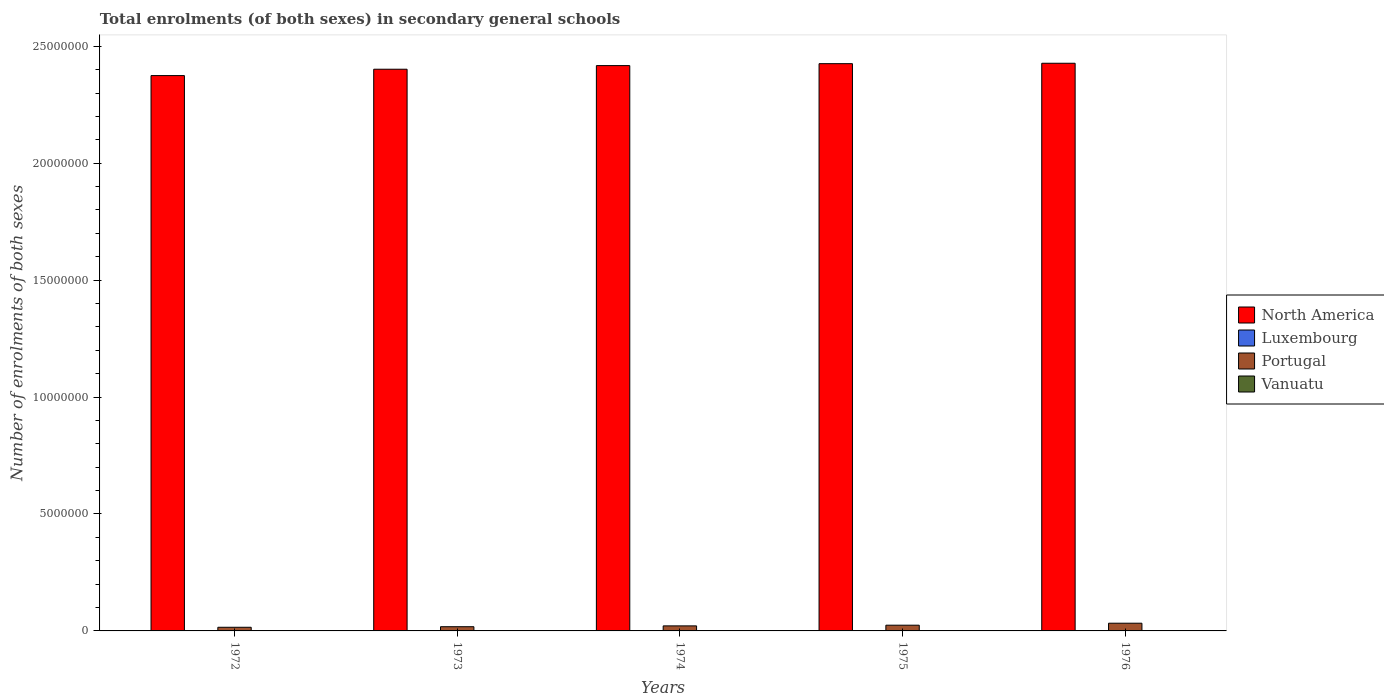How many different coloured bars are there?
Give a very brief answer. 4. Are the number of bars on each tick of the X-axis equal?
Provide a succinct answer. Yes. How many bars are there on the 3rd tick from the left?
Give a very brief answer. 4. How many bars are there on the 2nd tick from the right?
Ensure brevity in your answer.  4. What is the number of enrolments in secondary schools in North America in 1974?
Your response must be concise. 2.42e+07. Across all years, what is the maximum number of enrolments in secondary schools in North America?
Your response must be concise. 2.43e+07. Across all years, what is the minimum number of enrolments in secondary schools in Luxembourg?
Offer a very short reply. 8213. In which year was the number of enrolments in secondary schools in Luxembourg maximum?
Make the answer very short. 1976. In which year was the number of enrolments in secondary schools in Vanuatu minimum?
Make the answer very short. 1972. What is the total number of enrolments in secondary schools in Vanuatu in the graph?
Your answer should be compact. 5290. What is the difference between the number of enrolments in secondary schools in Portugal in 1972 and that in 1973?
Provide a succinct answer. -2.42e+04. What is the difference between the number of enrolments in secondary schools in North America in 1976 and the number of enrolments in secondary schools in Vanuatu in 1972?
Ensure brevity in your answer.  2.43e+07. What is the average number of enrolments in secondary schools in Luxembourg per year?
Keep it short and to the point. 1.11e+04. In the year 1973, what is the difference between the number of enrolments in secondary schools in North America and number of enrolments in secondary schools in Portugal?
Keep it short and to the point. 2.38e+07. In how many years, is the number of enrolments in secondary schools in Vanuatu greater than 23000000?
Offer a terse response. 0. What is the ratio of the number of enrolments in secondary schools in Portugal in 1972 to that in 1973?
Offer a terse response. 0.87. Is the difference between the number of enrolments in secondary schools in North America in 1972 and 1974 greater than the difference between the number of enrolments in secondary schools in Portugal in 1972 and 1974?
Give a very brief answer. No. What is the difference between the highest and the second highest number of enrolments in secondary schools in North America?
Your response must be concise. 1.73e+04. What is the difference between the highest and the lowest number of enrolments in secondary schools in North America?
Offer a terse response. 5.27e+05. In how many years, is the number of enrolments in secondary schools in North America greater than the average number of enrolments in secondary schools in North America taken over all years?
Give a very brief answer. 3. Is the sum of the number of enrolments in secondary schools in Vanuatu in 1973 and 1976 greater than the maximum number of enrolments in secondary schools in North America across all years?
Offer a very short reply. No. What does the 1st bar from the left in 1972 represents?
Your answer should be very brief. North America. Is it the case that in every year, the sum of the number of enrolments in secondary schools in North America and number of enrolments in secondary schools in Vanuatu is greater than the number of enrolments in secondary schools in Luxembourg?
Your response must be concise. Yes. How many bars are there?
Your response must be concise. 20. How many years are there in the graph?
Keep it short and to the point. 5. Are the values on the major ticks of Y-axis written in scientific E-notation?
Make the answer very short. No. Where does the legend appear in the graph?
Your answer should be compact. Center right. How many legend labels are there?
Offer a terse response. 4. How are the legend labels stacked?
Make the answer very short. Vertical. What is the title of the graph?
Give a very brief answer. Total enrolments (of both sexes) in secondary general schools. What is the label or title of the X-axis?
Provide a succinct answer. Years. What is the label or title of the Y-axis?
Provide a short and direct response. Number of enrolments of both sexes. What is the Number of enrolments of both sexes in North America in 1972?
Your answer should be very brief. 2.37e+07. What is the Number of enrolments of both sexes in Luxembourg in 1972?
Offer a very short reply. 8685. What is the Number of enrolments of both sexes in Portugal in 1972?
Make the answer very short. 1.56e+05. What is the Number of enrolments of both sexes of Vanuatu in 1972?
Give a very brief answer. 696. What is the Number of enrolments of both sexes of North America in 1973?
Ensure brevity in your answer.  2.40e+07. What is the Number of enrolments of both sexes of Luxembourg in 1973?
Give a very brief answer. 8425. What is the Number of enrolments of both sexes in Portugal in 1973?
Give a very brief answer. 1.80e+05. What is the Number of enrolments of both sexes of Vanuatu in 1973?
Your answer should be compact. 835. What is the Number of enrolments of both sexes of North America in 1974?
Offer a very short reply. 2.42e+07. What is the Number of enrolments of both sexes in Luxembourg in 1974?
Your answer should be compact. 8213. What is the Number of enrolments of both sexes in Portugal in 1974?
Keep it short and to the point. 2.15e+05. What is the Number of enrolments of both sexes in Vanuatu in 1974?
Offer a terse response. 1016. What is the Number of enrolments of both sexes of North America in 1975?
Give a very brief answer. 2.43e+07. What is the Number of enrolments of both sexes of Luxembourg in 1975?
Keep it short and to the point. 1.50e+04. What is the Number of enrolments of both sexes of Portugal in 1975?
Provide a short and direct response. 2.45e+05. What is the Number of enrolments of both sexes of Vanuatu in 1975?
Offer a very short reply. 1263. What is the Number of enrolments of both sexes of North America in 1976?
Ensure brevity in your answer.  2.43e+07. What is the Number of enrolments of both sexes in Luxembourg in 1976?
Give a very brief answer. 1.52e+04. What is the Number of enrolments of both sexes in Portugal in 1976?
Your answer should be compact. 3.30e+05. What is the Number of enrolments of both sexes of Vanuatu in 1976?
Offer a very short reply. 1480. Across all years, what is the maximum Number of enrolments of both sexes of North America?
Keep it short and to the point. 2.43e+07. Across all years, what is the maximum Number of enrolments of both sexes in Luxembourg?
Your response must be concise. 1.52e+04. Across all years, what is the maximum Number of enrolments of both sexes in Portugal?
Provide a succinct answer. 3.30e+05. Across all years, what is the maximum Number of enrolments of both sexes in Vanuatu?
Make the answer very short. 1480. Across all years, what is the minimum Number of enrolments of both sexes of North America?
Your response must be concise. 2.37e+07. Across all years, what is the minimum Number of enrolments of both sexes in Luxembourg?
Keep it short and to the point. 8213. Across all years, what is the minimum Number of enrolments of both sexes in Portugal?
Offer a terse response. 1.56e+05. Across all years, what is the minimum Number of enrolments of both sexes in Vanuatu?
Ensure brevity in your answer.  696. What is the total Number of enrolments of both sexes in North America in the graph?
Your answer should be compact. 1.20e+08. What is the total Number of enrolments of both sexes of Luxembourg in the graph?
Offer a very short reply. 5.55e+04. What is the total Number of enrolments of both sexes of Portugal in the graph?
Your answer should be very brief. 1.13e+06. What is the total Number of enrolments of both sexes of Vanuatu in the graph?
Your response must be concise. 5290. What is the difference between the Number of enrolments of both sexes of North America in 1972 and that in 1973?
Give a very brief answer. -2.72e+05. What is the difference between the Number of enrolments of both sexes in Luxembourg in 1972 and that in 1973?
Provide a succinct answer. 260. What is the difference between the Number of enrolments of both sexes of Portugal in 1972 and that in 1973?
Provide a short and direct response. -2.42e+04. What is the difference between the Number of enrolments of both sexes of Vanuatu in 1972 and that in 1973?
Your response must be concise. -139. What is the difference between the Number of enrolments of both sexes of North America in 1972 and that in 1974?
Make the answer very short. -4.27e+05. What is the difference between the Number of enrolments of both sexes in Luxembourg in 1972 and that in 1974?
Your response must be concise. 472. What is the difference between the Number of enrolments of both sexes in Portugal in 1972 and that in 1974?
Your response must be concise. -5.97e+04. What is the difference between the Number of enrolments of both sexes in Vanuatu in 1972 and that in 1974?
Ensure brevity in your answer.  -320. What is the difference between the Number of enrolments of both sexes of North America in 1972 and that in 1975?
Make the answer very short. -5.10e+05. What is the difference between the Number of enrolments of both sexes of Luxembourg in 1972 and that in 1975?
Make the answer very short. -6328. What is the difference between the Number of enrolments of both sexes of Portugal in 1972 and that in 1975?
Your answer should be very brief. -8.95e+04. What is the difference between the Number of enrolments of both sexes of Vanuatu in 1972 and that in 1975?
Provide a short and direct response. -567. What is the difference between the Number of enrolments of both sexes in North America in 1972 and that in 1976?
Your response must be concise. -5.27e+05. What is the difference between the Number of enrolments of both sexes of Luxembourg in 1972 and that in 1976?
Your answer should be compact. -6506. What is the difference between the Number of enrolments of both sexes in Portugal in 1972 and that in 1976?
Your answer should be compact. -1.74e+05. What is the difference between the Number of enrolments of both sexes of Vanuatu in 1972 and that in 1976?
Offer a terse response. -784. What is the difference between the Number of enrolments of both sexes of North America in 1973 and that in 1974?
Give a very brief answer. -1.55e+05. What is the difference between the Number of enrolments of both sexes of Luxembourg in 1973 and that in 1974?
Provide a short and direct response. 212. What is the difference between the Number of enrolments of both sexes of Portugal in 1973 and that in 1974?
Your answer should be compact. -3.55e+04. What is the difference between the Number of enrolments of both sexes in Vanuatu in 1973 and that in 1974?
Make the answer very short. -181. What is the difference between the Number of enrolments of both sexes in North America in 1973 and that in 1975?
Keep it short and to the point. -2.38e+05. What is the difference between the Number of enrolments of both sexes in Luxembourg in 1973 and that in 1975?
Offer a terse response. -6588. What is the difference between the Number of enrolments of both sexes in Portugal in 1973 and that in 1975?
Give a very brief answer. -6.53e+04. What is the difference between the Number of enrolments of both sexes in Vanuatu in 1973 and that in 1975?
Make the answer very short. -428. What is the difference between the Number of enrolments of both sexes in North America in 1973 and that in 1976?
Give a very brief answer. -2.55e+05. What is the difference between the Number of enrolments of both sexes of Luxembourg in 1973 and that in 1976?
Provide a succinct answer. -6766. What is the difference between the Number of enrolments of both sexes in Portugal in 1973 and that in 1976?
Ensure brevity in your answer.  -1.50e+05. What is the difference between the Number of enrolments of both sexes in Vanuatu in 1973 and that in 1976?
Give a very brief answer. -645. What is the difference between the Number of enrolments of both sexes of North America in 1974 and that in 1975?
Give a very brief answer. -8.29e+04. What is the difference between the Number of enrolments of both sexes of Luxembourg in 1974 and that in 1975?
Provide a succinct answer. -6800. What is the difference between the Number of enrolments of both sexes of Portugal in 1974 and that in 1975?
Provide a succinct answer. -2.98e+04. What is the difference between the Number of enrolments of both sexes of Vanuatu in 1974 and that in 1975?
Your response must be concise. -247. What is the difference between the Number of enrolments of both sexes of North America in 1974 and that in 1976?
Make the answer very short. -1.00e+05. What is the difference between the Number of enrolments of both sexes in Luxembourg in 1974 and that in 1976?
Provide a short and direct response. -6978. What is the difference between the Number of enrolments of both sexes in Portugal in 1974 and that in 1976?
Ensure brevity in your answer.  -1.15e+05. What is the difference between the Number of enrolments of both sexes of Vanuatu in 1974 and that in 1976?
Give a very brief answer. -464. What is the difference between the Number of enrolments of both sexes in North America in 1975 and that in 1976?
Offer a terse response. -1.73e+04. What is the difference between the Number of enrolments of both sexes in Luxembourg in 1975 and that in 1976?
Offer a very short reply. -178. What is the difference between the Number of enrolments of both sexes in Portugal in 1975 and that in 1976?
Your response must be concise. -8.48e+04. What is the difference between the Number of enrolments of both sexes of Vanuatu in 1975 and that in 1976?
Offer a terse response. -217. What is the difference between the Number of enrolments of both sexes of North America in 1972 and the Number of enrolments of both sexes of Luxembourg in 1973?
Ensure brevity in your answer.  2.37e+07. What is the difference between the Number of enrolments of both sexes in North America in 1972 and the Number of enrolments of both sexes in Portugal in 1973?
Give a very brief answer. 2.36e+07. What is the difference between the Number of enrolments of both sexes in North America in 1972 and the Number of enrolments of both sexes in Vanuatu in 1973?
Offer a very short reply. 2.37e+07. What is the difference between the Number of enrolments of both sexes in Luxembourg in 1972 and the Number of enrolments of both sexes in Portugal in 1973?
Give a very brief answer. -1.71e+05. What is the difference between the Number of enrolments of both sexes of Luxembourg in 1972 and the Number of enrolments of both sexes of Vanuatu in 1973?
Give a very brief answer. 7850. What is the difference between the Number of enrolments of both sexes in Portugal in 1972 and the Number of enrolments of both sexes in Vanuatu in 1973?
Your response must be concise. 1.55e+05. What is the difference between the Number of enrolments of both sexes in North America in 1972 and the Number of enrolments of both sexes in Luxembourg in 1974?
Your answer should be compact. 2.37e+07. What is the difference between the Number of enrolments of both sexes of North America in 1972 and the Number of enrolments of both sexes of Portugal in 1974?
Ensure brevity in your answer.  2.35e+07. What is the difference between the Number of enrolments of both sexes of North America in 1972 and the Number of enrolments of both sexes of Vanuatu in 1974?
Provide a short and direct response. 2.37e+07. What is the difference between the Number of enrolments of both sexes of Luxembourg in 1972 and the Number of enrolments of both sexes of Portugal in 1974?
Provide a short and direct response. -2.07e+05. What is the difference between the Number of enrolments of both sexes in Luxembourg in 1972 and the Number of enrolments of both sexes in Vanuatu in 1974?
Your answer should be very brief. 7669. What is the difference between the Number of enrolments of both sexes in Portugal in 1972 and the Number of enrolments of both sexes in Vanuatu in 1974?
Your answer should be compact. 1.55e+05. What is the difference between the Number of enrolments of both sexes of North America in 1972 and the Number of enrolments of both sexes of Luxembourg in 1975?
Keep it short and to the point. 2.37e+07. What is the difference between the Number of enrolments of both sexes of North America in 1972 and the Number of enrolments of both sexes of Portugal in 1975?
Your answer should be very brief. 2.35e+07. What is the difference between the Number of enrolments of both sexes of North America in 1972 and the Number of enrolments of both sexes of Vanuatu in 1975?
Make the answer very short. 2.37e+07. What is the difference between the Number of enrolments of both sexes of Luxembourg in 1972 and the Number of enrolments of both sexes of Portugal in 1975?
Your response must be concise. -2.36e+05. What is the difference between the Number of enrolments of both sexes in Luxembourg in 1972 and the Number of enrolments of both sexes in Vanuatu in 1975?
Your response must be concise. 7422. What is the difference between the Number of enrolments of both sexes in Portugal in 1972 and the Number of enrolments of both sexes in Vanuatu in 1975?
Give a very brief answer. 1.54e+05. What is the difference between the Number of enrolments of both sexes of North America in 1972 and the Number of enrolments of both sexes of Luxembourg in 1976?
Offer a terse response. 2.37e+07. What is the difference between the Number of enrolments of both sexes of North America in 1972 and the Number of enrolments of both sexes of Portugal in 1976?
Give a very brief answer. 2.34e+07. What is the difference between the Number of enrolments of both sexes of North America in 1972 and the Number of enrolments of both sexes of Vanuatu in 1976?
Your response must be concise. 2.37e+07. What is the difference between the Number of enrolments of both sexes of Luxembourg in 1972 and the Number of enrolments of both sexes of Portugal in 1976?
Provide a succinct answer. -3.21e+05. What is the difference between the Number of enrolments of both sexes of Luxembourg in 1972 and the Number of enrolments of both sexes of Vanuatu in 1976?
Make the answer very short. 7205. What is the difference between the Number of enrolments of both sexes of Portugal in 1972 and the Number of enrolments of both sexes of Vanuatu in 1976?
Your response must be concise. 1.54e+05. What is the difference between the Number of enrolments of both sexes of North America in 1973 and the Number of enrolments of both sexes of Luxembourg in 1974?
Your answer should be very brief. 2.40e+07. What is the difference between the Number of enrolments of both sexes of North America in 1973 and the Number of enrolments of both sexes of Portugal in 1974?
Ensure brevity in your answer.  2.38e+07. What is the difference between the Number of enrolments of both sexes of North America in 1973 and the Number of enrolments of both sexes of Vanuatu in 1974?
Offer a terse response. 2.40e+07. What is the difference between the Number of enrolments of both sexes of Luxembourg in 1973 and the Number of enrolments of both sexes of Portugal in 1974?
Provide a short and direct response. -2.07e+05. What is the difference between the Number of enrolments of both sexes of Luxembourg in 1973 and the Number of enrolments of both sexes of Vanuatu in 1974?
Make the answer very short. 7409. What is the difference between the Number of enrolments of both sexes in Portugal in 1973 and the Number of enrolments of both sexes in Vanuatu in 1974?
Provide a short and direct response. 1.79e+05. What is the difference between the Number of enrolments of both sexes of North America in 1973 and the Number of enrolments of both sexes of Luxembourg in 1975?
Offer a very short reply. 2.40e+07. What is the difference between the Number of enrolments of both sexes in North America in 1973 and the Number of enrolments of both sexes in Portugal in 1975?
Your answer should be very brief. 2.38e+07. What is the difference between the Number of enrolments of both sexes in North America in 1973 and the Number of enrolments of both sexes in Vanuatu in 1975?
Your answer should be compact. 2.40e+07. What is the difference between the Number of enrolments of both sexes of Luxembourg in 1973 and the Number of enrolments of both sexes of Portugal in 1975?
Give a very brief answer. -2.37e+05. What is the difference between the Number of enrolments of both sexes of Luxembourg in 1973 and the Number of enrolments of both sexes of Vanuatu in 1975?
Provide a succinct answer. 7162. What is the difference between the Number of enrolments of both sexes in Portugal in 1973 and the Number of enrolments of both sexes in Vanuatu in 1975?
Provide a short and direct response. 1.79e+05. What is the difference between the Number of enrolments of both sexes in North America in 1973 and the Number of enrolments of both sexes in Luxembourg in 1976?
Ensure brevity in your answer.  2.40e+07. What is the difference between the Number of enrolments of both sexes of North America in 1973 and the Number of enrolments of both sexes of Portugal in 1976?
Offer a very short reply. 2.37e+07. What is the difference between the Number of enrolments of both sexes in North America in 1973 and the Number of enrolments of both sexes in Vanuatu in 1976?
Offer a terse response. 2.40e+07. What is the difference between the Number of enrolments of both sexes of Luxembourg in 1973 and the Number of enrolments of both sexes of Portugal in 1976?
Give a very brief answer. -3.22e+05. What is the difference between the Number of enrolments of both sexes of Luxembourg in 1973 and the Number of enrolments of both sexes of Vanuatu in 1976?
Provide a succinct answer. 6945. What is the difference between the Number of enrolments of both sexes in Portugal in 1973 and the Number of enrolments of both sexes in Vanuatu in 1976?
Make the answer very short. 1.78e+05. What is the difference between the Number of enrolments of both sexes in North America in 1974 and the Number of enrolments of both sexes in Luxembourg in 1975?
Your answer should be very brief. 2.42e+07. What is the difference between the Number of enrolments of both sexes of North America in 1974 and the Number of enrolments of both sexes of Portugal in 1975?
Your answer should be compact. 2.39e+07. What is the difference between the Number of enrolments of both sexes of North America in 1974 and the Number of enrolments of both sexes of Vanuatu in 1975?
Provide a short and direct response. 2.42e+07. What is the difference between the Number of enrolments of both sexes of Luxembourg in 1974 and the Number of enrolments of both sexes of Portugal in 1975?
Make the answer very short. -2.37e+05. What is the difference between the Number of enrolments of both sexes in Luxembourg in 1974 and the Number of enrolments of both sexes in Vanuatu in 1975?
Offer a terse response. 6950. What is the difference between the Number of enrolments of both sexes of Portugal in 1974 and the Number of enrolments of both sexes of Vanuatu in 1975?
Make the answer very short. 2.14e+05. What is the difference between the Number of enrolments of both sexes of North America in 1974 and the Number of enrolments of both sexes of Luxembourg in 1976?
Offer a very short reply. 2.42e+07. What is the difference between the Number of enrolments of both sexes in North America in 1974 and the Number of enrolments of both sexes in Portugal in 1976?
Offer a very short reply. 2.38e+07. What is the difference between the Number of enrolments of both sexes in North America in 1974 and the Number of enrolments of both sexes in Vanuatu in 1976?
Your response must be concise. 2.42e+07. What is the difference between the Number of enrolments of both sexes in Luxembourg in 1974 and the Number of enrolments of both sexes in Portugal in 1976?
Provide a short and direct response. -3.22e+05. What is the difference between the Number of enrolments of both sexes in Luxembourg in 1974 and the Number of enrolments of both sexes in Vanuatu in 1976?
Your answer should be very brief. 6733. What is the difference between the Number of enrolments of both sexes in Portugal in 1974 and the Number of enrolments of both sexes in Vanuatu in 1976?
Your answer should be compact. 2.14e+05. What is the difference between the Number of enrolments of both sexes of North America in 1975 and the Number of enrolments of both sexes of Luxembourg in 1976?
Provide a short and direct response. 2.42e+07. What is the difference between the Number of enrolments of both sexes of North America in 1975 and the Number of enrolments of both sexes of Portugal in 1976?
Provide a succinct answer. 2.39e+07. What is the difference between the Number of enrolments of both sexes in North America in 1975 and the Number of enrolments of both sexes in Vanuatu in 1976?
Offer a terse response. 2.43e+07. What is the difference between the Number of enrolments of both sexes of Luxembourg in 1975 and the Number of enrolments of both sexes of Portugal in 1976?
Offer a very short reply. -3.15e+05. What is the difference between the Number of enrolments of both sexes of Luxembourg in 1975 and the Number of enrolments of both sexes of Vanuatu in 1976?
Offer a terse response. 1.35e+04. What is the difference between the Number of enrolments of both sexes of Portugal in 1975 and the Number of enrolments of both sexes of Vanuatu in 1976?
Offer a terse response. 2.44e+05. What is the average Number of enrolments of both sexes in North America per year?
Your response must be concise. 2.41e+07. What is the average Number of enrolments of both sexes of Luxembourg per year?
Ensure brevity in your answer.  1.11e+04. What is the average Number of enrolments of both sexes of Portugal per year?
Make the answer very short. 2.25e+05. What is the average Number of enrolments of both sexes of Vanuatu per year?
Your response must be concise. 1058. In the year 1972, what is the difference between the Number of enrolments of both sexes of North America and Number of enrolments of both sexes of Luxembourg?
Give a very brief answer. 2.37e+07. In the year 1972, what is the difference between the Number of enrolments of both sexes of North America and Number of enrolments of both sexes of Portugal?
Offer a terse response. 2.36e+07. In the year 1972, what is the difference between the Number of enrolments of both sexes of North America and Number of enrolments of both sexes of Vanuatu?
Give a very brief answer. 2.37e+07. In the year 1972, what is the difference between the Number of enrolments of both sexes of Luxembourg and Number of enrolments of both sexes of Portugal?
Offer a very short reply. -1.47e+05. In the year 1972, what is the difference between the Number of enrolments of both sexes in Luxembourg and Number of enrolments of both sexes in Vanuatu?
Keep it short and to the point. 7989. In the year 1972, what is the difference between the Number of enrolments of both sexes in Portugal and Number of enrolments of both sexes in Vanuatu?
Ensure brevity in your answer.  1.55e+05. In the year 1973, what is the difference between the Number of enrolments of both sexes of North America and Number of enrolments of both sexes of Luxembourg?
Provide a short and direct response. 2.40e+07. In the year 1973, what is the difference between the Number of enrolments of both sexes of North America and Number of enrolments of both sexes of Portugal?
Offer a terse response. 2.38e+07. In the year 1973, what is the difference between the Number of enrolments of both sexes of North America and Number of enrolments of both sexes of Vanuatu?
Ensure brevity in your answer.  2.40e+07. In the year 1973, what is the difference between the Number of enrolments of both sexes in Luxembourg and Number of enrolments of both sexes in Portugal?
Offer a terse response. -1.71e+05. In the year 1973, what is the difference between the Number of enrolments of both sexes in Luxembourg and Number of enrolments of both sexes in Vanuatu?
Provide a succinct answer. 7590. In the year 1973, what is the difference between the Number of enrolments of both sexes in Portugal and Number of enrolments of both sexes in Vanuatu?
Offer a very short reply. 1.79e+05. In the year 1974, what is the difference between the Number of enrolments of both sexes of North America and Number of enrolments of both sexes of Luxembourg?
Provide a short and direct response. 2.42e+07. In the year 1974, what is the difference between the Number of enrolments of both sexes of North America and Number of enrolments of both sexes of Portugal?
Offer a very short reply. 2.40e+07. In the year 1974, what is the difference between the Number of enrolments of both sexes in North America and Number of enrolments of both sexes in Vanuatu?
Make the answer very short. 2.42e+07. In the year 1974, what is the difference between the Number of enrolments of both sexes in Luxembourg and Number of enrolments of both sexes in Portugal?
Give a very brief answer. -2.07e+05. In the year 1974, what is the difference between the Number of enrolments of both sexes in Luxembourg and Number of enrolments of both sexes in Vanuatu?
Your answer should be very brief. 7197. In the year 1974, what is the difference between the Number of enrolments of both sexes in Portugal and Number of enrolments of both sexes in Vanuatu?
Give a very brief answer. 2.14e+05. In the year 1975, what is the difference between the Number of enrolments of both sexes of North America and Number of enrolments of both sexes of Luxembourg?
Offer a very short reply. 2.42e+07. In the year 1975, what is the difference between the Number of enrolments of both sexes in North America and Number of enrolments of both sexes in Portugal?
Offer a terse response. 2.40e+07. In the year 1975, what is the difference between the Number of enrolments of both sexes in North America and Number of enrolments of both sexes in Vanuatu?
Offer a very short reply. 2.43e+07. In the year 1975, what is the difference between the Number of enrolments of both sexes in Luxembourg and Number of enrolments of both sexes in Portugal?
Your response must be concise. -2.30e+05. In the year 1975, what is the difference between the Number of enrolments of both sexes of Luxembourg and Number of enrolments of both sexes of Vanuatu?
Offer a terse response. 1.38e+04. In the year 1975, what is the difference between the Number of enrolments of both sexes in Portugal and Number of enrolments of both sexes in Vanuatu?
Provide a short and direct response. 2.44e+05. In the year 1976, what is the difference between the Number of enrolments of both sexes in North America and Number of enrolments of both sexes in Luxembourg?
Offer a very short reply. 2.43e+07. In the year 1976, what is the difference between the Number of enrolments of both sexes in North America and Number of enrolments of both sexes in Portugal?
Offer a very short reply. 2.39e+07. In the year 1976, what is the difference between the Number of enrolments of both sexes of North America and Number of enrolments of both sexes of Vanuatu?
Make the answer very short. 2.43e+07. In the year 1976, what is the difference between the Number of enrolments of both sexes in Luxembourg and Number of enrolments of both sexes in Portugal?
Provide a succinct answer. -3.15e+05. In the year 1976, what is the difference between the Number of enrolments of both sexes of Luxembourg and Number of enrolments of both sexes of Vanuatu?
Make the answer very short. 1.37e+04. In the year 1976, what is the difference between the Number of enrolments of both sexes of Portugal and Number of enrolments of both sexes of Vanuatu?
Give a very brief answer. 3.29e+05. What is the ratio of the Number of enrolments of both sexes of North America in 1972 to that in 1973?
Ensure brevity in your answer.  0.99. What is the ratio of the Number of enrolments of both sexes in Luxembourg in 1972 to that in 1973?
Give a very brief answer. 1.03. What is the ratio of the Number of enrolments of both sexes of Portugal in 1972 to that in 1973?
Provide a short and direct response. 0.87. What is the ratio of the Number of enrolments of both sexes of Vanuatu in 1972 to that in 1973?
Keep it short and to the point. 0.83. What is the ratio of the Number of enrolments of both sexes in North America in 1972 to that in 1974?
Your answer should be very brief. 0.98. What is the ratio of the Number of enrolments of both sexes of Luxembourg in 1972 to that in 1974?
Keep it short and to the point. 1.06. What is the ratio of the Number of enrolments of both sexes in Portugal in 1972 to that in 1974?
Your answer should be compact. 0.72. What is the ratio of the Number of enrolments of both sexes in Vanuatu in 1972 to that in 1974?
Give a very brief answer. 0.69. What is the ratio of the Number of enrolments of both sexes in Luxembourg in 1972 to that in 1975?
Your answer should be very brief. 0.58. What is the ratio of the Number of enrolments of both sexes of Portugal in 1972 to that in 1975?
Ensure brevity in your answer.  0.64. What is the ratio of the Number of enrolments of both sexes of Vanuatu in 1972 to that in 1975?
Provide a short and direct response. 0.55. What is the ratio of the Number of enrolments of both sexes of North America in 1972 to that in 1976?
Offer a very short reply. 0.98. What is the ratio of the Number of enrolments of both sexes of Luxembourg in 1972 to that in 1976?
Give a very brief answer. 0.57. What is the ratio of the Number of enrolments of both sexes of Portugal in 1972 to that in 1976?
Your answer should be compact. 0.47. What is the ratio of the Number of enrolments of both sexes in Vanuatu in 1972 to that in 1976?
Offer a very short reply. 0.47. What is the ratio of the Number of enrolments of both sexes in North America in 1973 to that in 1974?
Your answer should be compact. 0.99. What is the ratio of the Number of enrolments of both sexes of Luxembourg in 1973 to that in 1974?
Keep it short and to the point. 1.03. What is the ratio of the Number of enrolments of both sexes of Portugal in 1973 to that in 1974?
Make the answer very short. 0.84. What is the ratio of the Number of enrolments of both sexes of Vanuatu in 1973 to that in 1974?
Ensure brevity in your answer.  0.82. What is the ratio of the Number of enrolments of both sexes in North America in 1973 to that in 1975?
Your response must be concise. 0.99. What is the ratio of the Number of enrolments of both sexes in Luxembourg in 1973 to that in 1975?
Ensure brevity in your answer.  0.56. What is the ratio of the Number of enrolments of both sexes of Portugal in 1973 to that in 1975?
Make the answer very short. 0.73. What is the ratio of the Number of enrolments of both sexes of Vanuatu in 1973 to that in 1975?
Ensure brevity in your answer.  0.66. What is the ratio of the Number of enrolments of both sexes of Luxembourg in 1973 to that in 1976?
Provide a short and direct response. 0.55. What is the ratio of the Number of enrolments of both sexes of Portugal in 1973 to that in 1976?
Make the answer very short. 0.55. What is the ratio of the Number of enrolments of both sexes in Vanuatu in 1973 to that in 1976?
Your response must be concise. 0.56. What is the ratio of the Number of enrolments of both sexes in Luxembourg in 1974 to that in 1975?
Ensure brevity in your answer.  0.55. What is the ratio of the Number of enrolments of both sexes in Portugal in 1974 to that in 1975?
Your answer should be compact. 0.88. What is the ratio of the Number of enrolments of both sexes in Vanuatu in 1974 to that in 1975?
Ensure brevity in your answer.  0.8. What is the ratio of the Number of enrolments of both sexes in Luxembourg in 1974 to that in 1976?
Ensure brevity in your answer.  0.54. What is the ratio of the Number of enrolments of both sexes of Portugal in 1974 to that in 1976?
Provide a succinct answer. 0.65. What is the ratio of the Number of enrolments of both sexes of Vanuatu in 1974 to that in 1976?
Make the answer very short. 0.69. What is the ratio of the Number of enrolments of both sexes in Luxembourg in 1975 to that in 1976?
Ensure brevity in your answer.  0.99. What is the ratio of the Number of enrolments of both sexes of Portugal in 1975 to that in 1976?
Keep it short and to the point. 0.74. What is the ratio of the Number of enrolments of both sexes in Vanuatu in 1975 to that in 1976?
Your answer should be compact. 0.85. What is the difference between the highest and the second highest Number of enrolments of both sexes in North America?
Make the answer very short. 1.73e+04. What is the difference between the highest and the second highest Number of enrolments of both sexes in Luxembourg?
Your answer should be compact. 178. What is the difference between the highest and the second highest Number of enrolments of both sexes in Portugal?
Your answer should be very brief. 8.48e+04. What is the difference between the highest and the second highest Number of enrolments of both sexes in Vanuatu?
Your answer should be compact. 217. What is the difference between the highest and the lowest Number of enrolments of both sexes of North America?
Make the answer very short. 5.27e+05. What is the difference between the highest and the lowest Number of enrolments of both sexes in Luxembourg?
Your answer should be compact. 6978. What is the difference between the highest and the lowest Number of enrolments of both sexes of Portugal?
Ensure brevity in your answer.  1.74e+05. What is the difference between the highest and the lowest Number of enrolments of both sexes of Vanuatu?
Give a very brief answer. 784. 